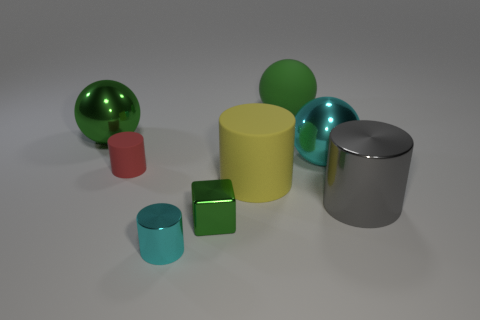Add 1 large blue rubber things. How many objects exist? 9 Subtract all large metallic cylinders. How many cylinders are left? 3 Subtract all green spheres. How many spheres are left? 1 Subtract 1 green cubes. How many objects are left? 7 Subtract all balls. How many objects are left? 5 Subtract 1 balls. How many balls are left? 2 Subtract all purple cylinders. Subtract all red cubes. How many cylinders are left? 4 Subtract all brown cubes. How many cyan cylinders are left? 1 Subtract all red matte objects. Subtract all big green matte balls. How many objects are left? 6 Add 2 green metallic objects. How many green metallic objects are left? 4 